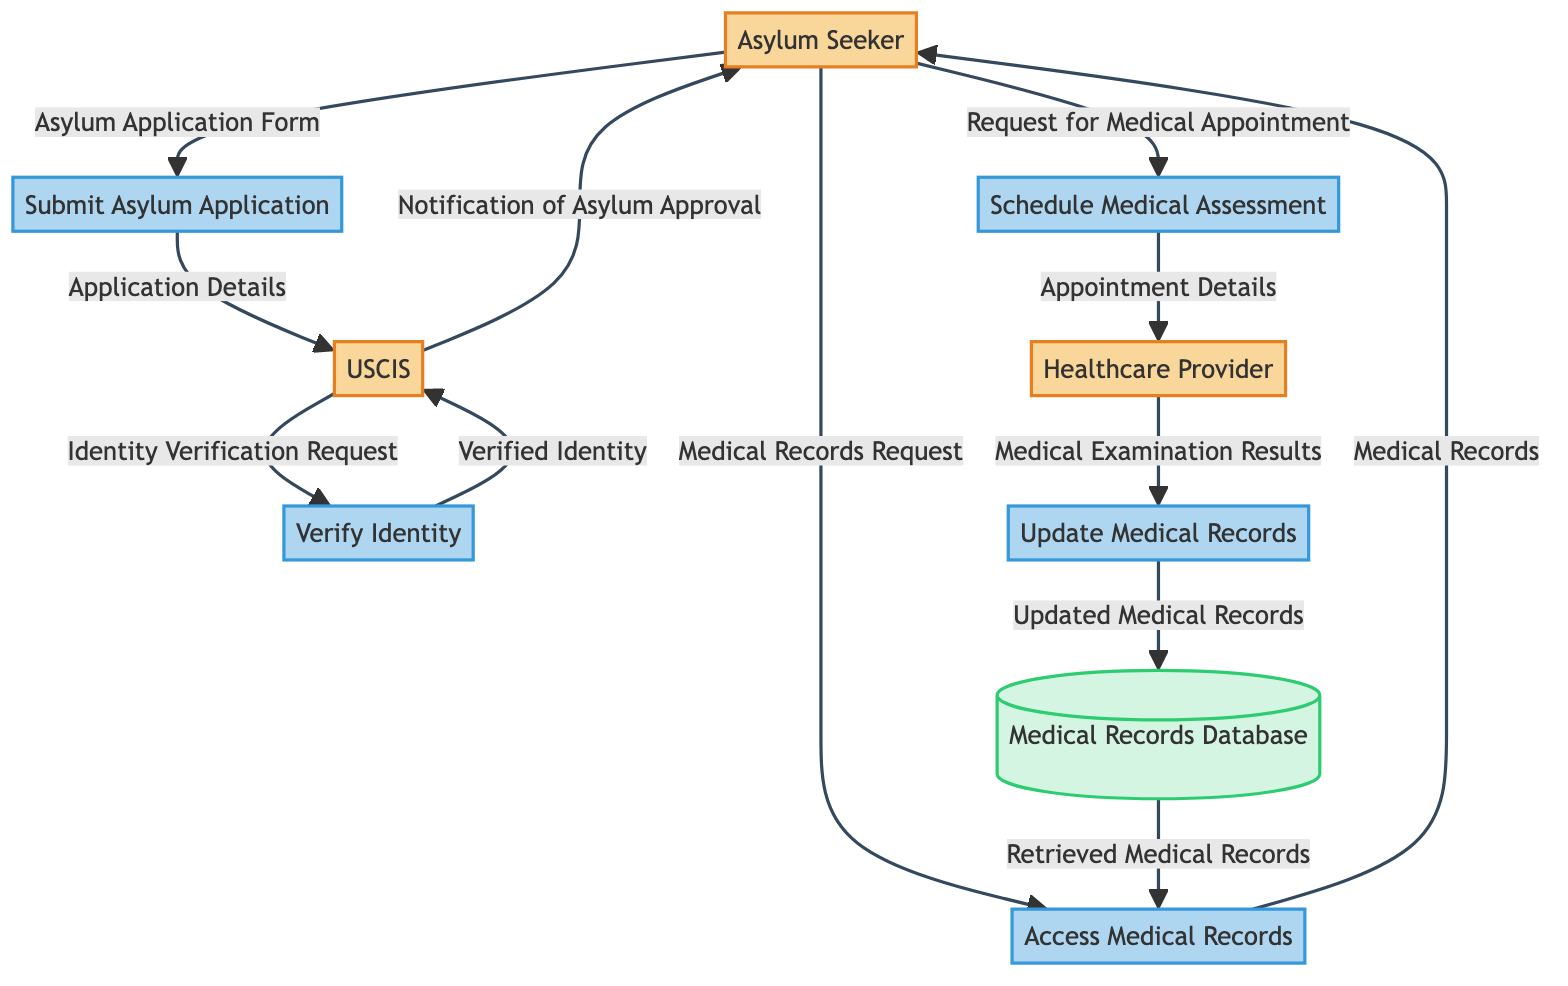What is the first process in the diagram? The first process in the diagram is "Submit Asylum Application," which is directly connected to the Asylum Seeker entity.
Answer: Submit Asylum Application How many external entities are present in the diagram? The diagram includes three external entities: Asylum Seeker, Healthcare Provider, and USCIS.
Answer: Three What type of data flow occurs between USCIS and the Verify Identity process? The data flow from USCIS to the Verify Identity process is labeled "Identity Verification Request," indicating an output from USCIS.
Answer: Identity Verification Request What is the output of the Update Medical Records process? The output of the Update Medical Records process is directed to the Medical Records Database as "Updated Medical Records." This shows that the updated information is stored in the database.
Answer: Updated Medical Records Who sends a Medical Records Request? The Asylum Seeker sends a Medical Records Request to access their medical records, as shown in the data flow leading to the Access Medical Records process.
Answer: Asylum Seeker What happens after the USCIS process verifies the identity? After verifying the identity, USCIS issues a "Notification of Asylum Approval" to the Asylum Seeker, which is the output from the USCIS process.
Answer: Notification of Asylum Approval List the processes that involve healthcare providers. The processes involving healthcare providers are "Schedule Medical Assessment" and "Update Medical Records." These processes are directly connected to the Healthcare Provider external entity.
Answer: Schedule Medical Assessment, Update Medical Records How is medical data updated in the database? Medical data is updated in the Medical Records Database through the "Update Medical Records" process, which receives medical examination results from the Healthcare Provider as input.
Answer: Through Update Medical Records What does the Access Medical Records process output? The output of the Access Medical Records process is "Medical Records," which are retrieved from the Medical Records Database and sent to the Asylum Seeker.
Answer: Medical Records 